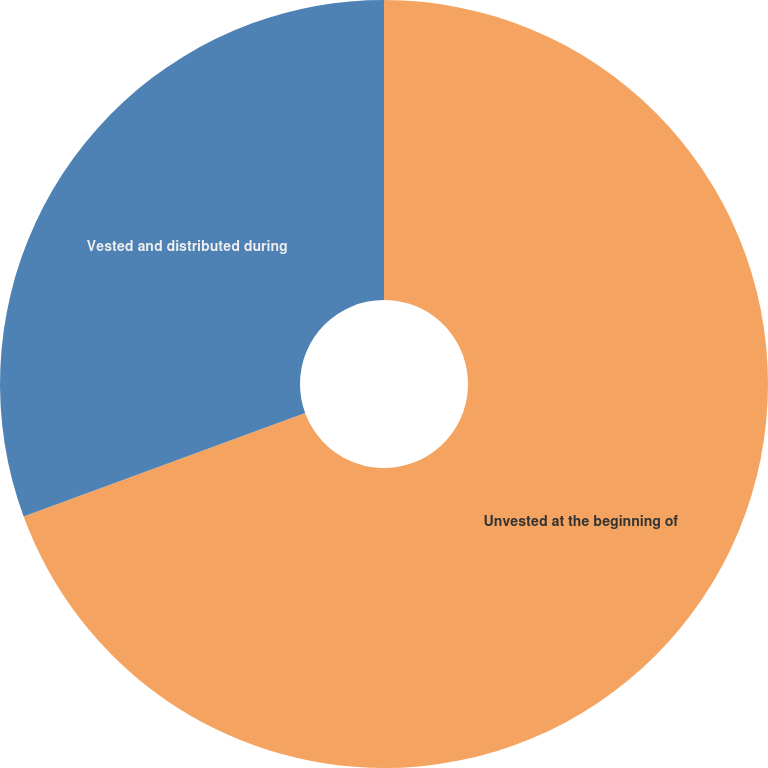Convert chart. <chart><loc_0><loc_0><loc_500><loc_500><pie_chart><fcel>Unvested at the beginning of<fcel>Vested and distributed during<nl><fcel>69.39%<fcel>30.61%<nl></chart> 